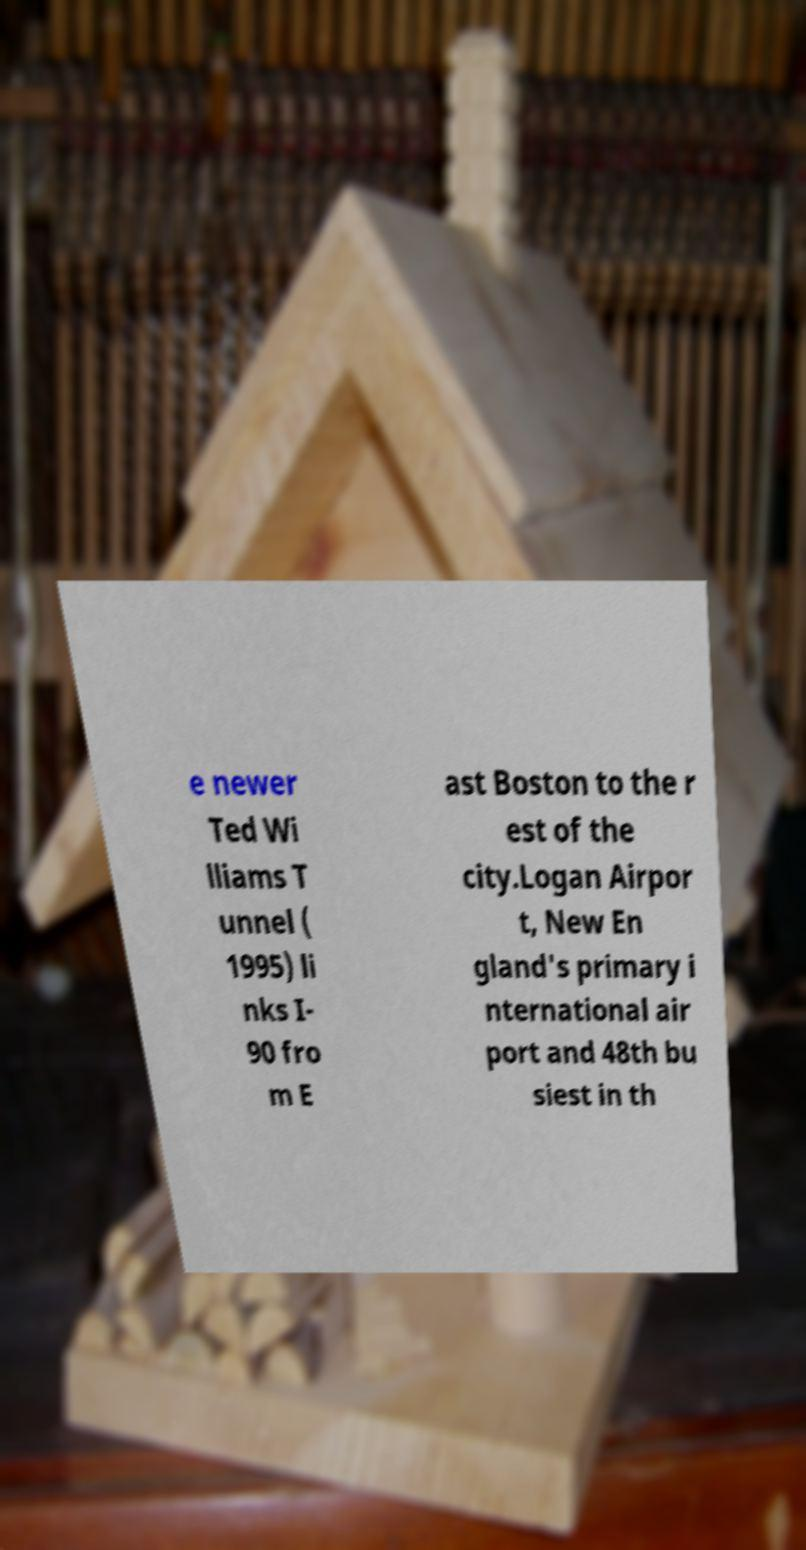Can you read and provide the text displayed in the image?This photo seems to have some interesting text. Can you extract and type it out for me? e newer Ted Wi lliams T unnel ( 1995) li nks I- 90 fro m E ast Boston to the r est of the city.Logan Airpor t, New En gland's primary i nternational air port and 48th bu siest in th 